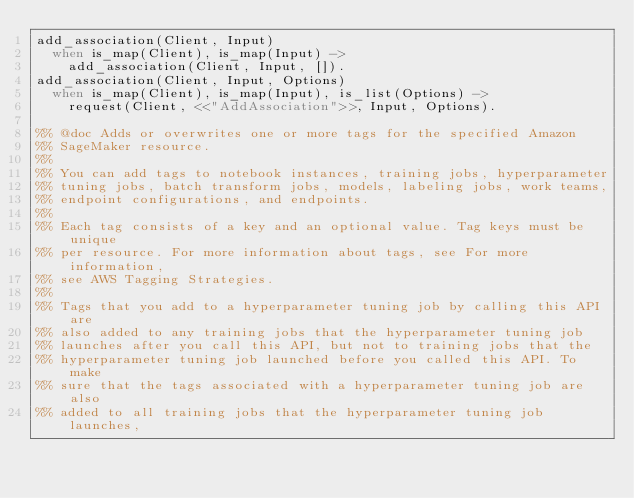Convert code to text. <code><loc_0><loc_0><loc_500><loc_500><_Erlang_>add_association(Client, Input)
  when is_map(Client), is_map(Input) ->
    add_association(Client, Input, []).
add_association(Client, Input, Options)
  when is_map(Client), is_map(Input), is_list(Options) ->
    request(Client, <<"AddAssociation">>, Input, Options).

%% @doc Adds or overwrites one or more tags for the specified Amazon
%% SageMaker resource.
%%
%% You can add tags to notebook instances, training jobs, hyperparameter
%% tuning jobs, batch transform jobs, models, labeling jobs, work teams,
%% endpoint configurations, and endpoints.
%%
%% Each tag consists of a key and an optional value. Tag keys must be unique
%% per resource. For more information about tags, see For more information,
%% see AWS Tagging Strategies.
%%
%% Tags that you add to a hyperparameter tuning job by calling this API are
%% also added to any training jobs that the hyperparameter tuning job
%% launches after you call this API, but not to training jobs that the
%% hyperparameter tuning job launched before you called this API. To make
%% sure that the tags associated with a hyperparameter tuning job are also
%% added to all training jobs that the hyperparameter tuning job launches,</code> 